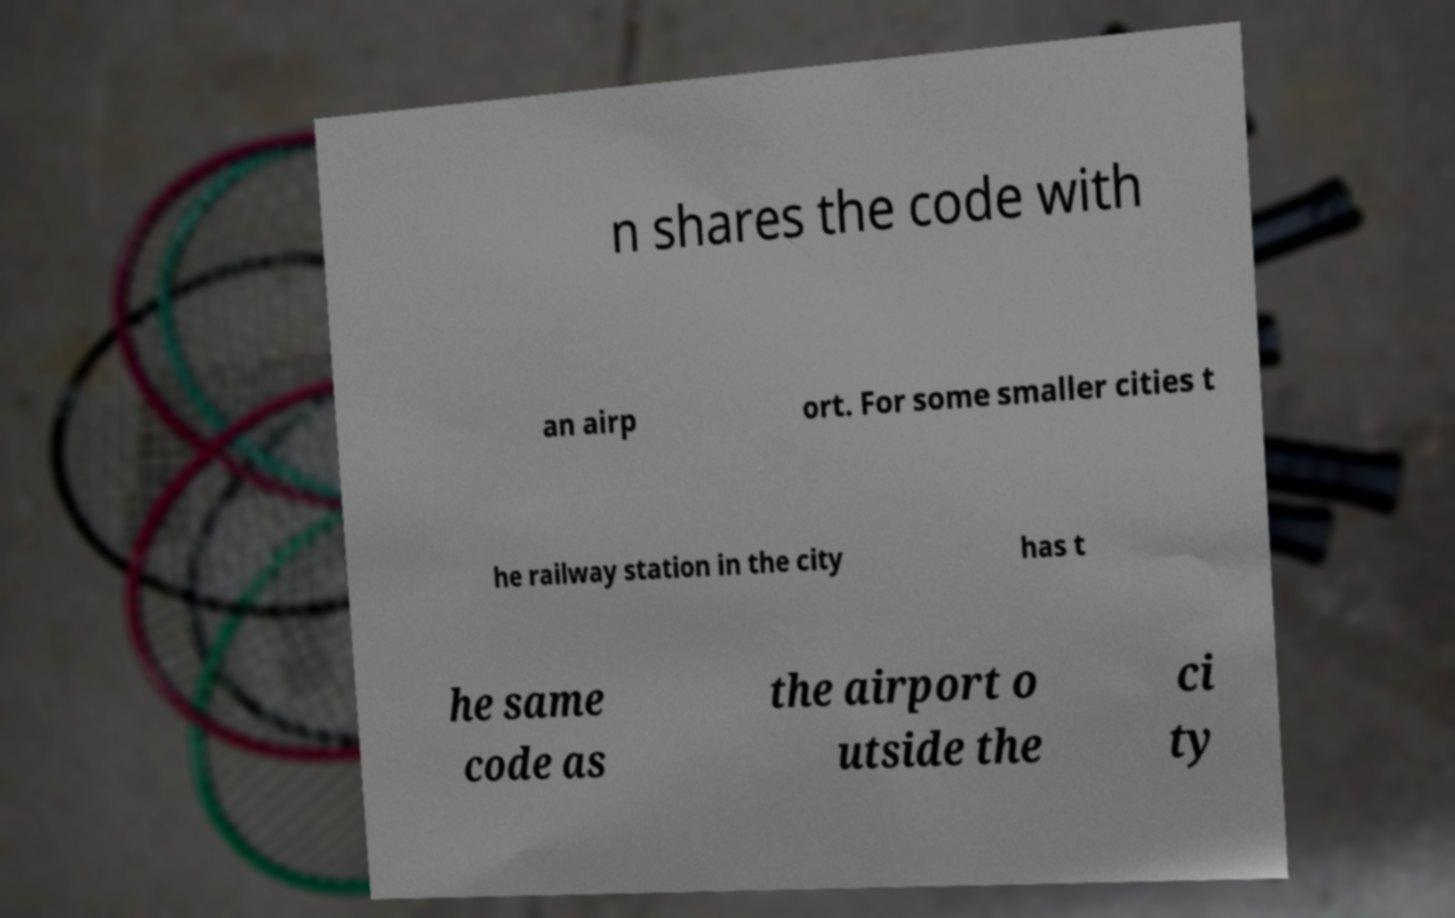Can you read and provide the text displayed in the image?This photo seems to have some interesting text. Can you extract and type it out for me? n shares the code with an airp ort. For some smaller cities t he railway station in the city has t he same code as the airport o utside the ci ty 